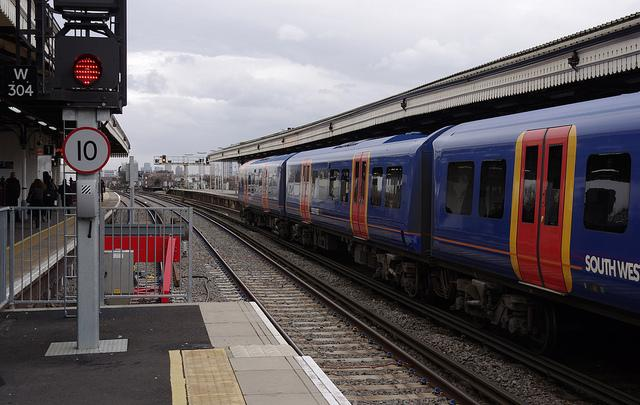What airline is advertised on the train? Please explain your reasoning. southwest. You can see the words next to the train door. 